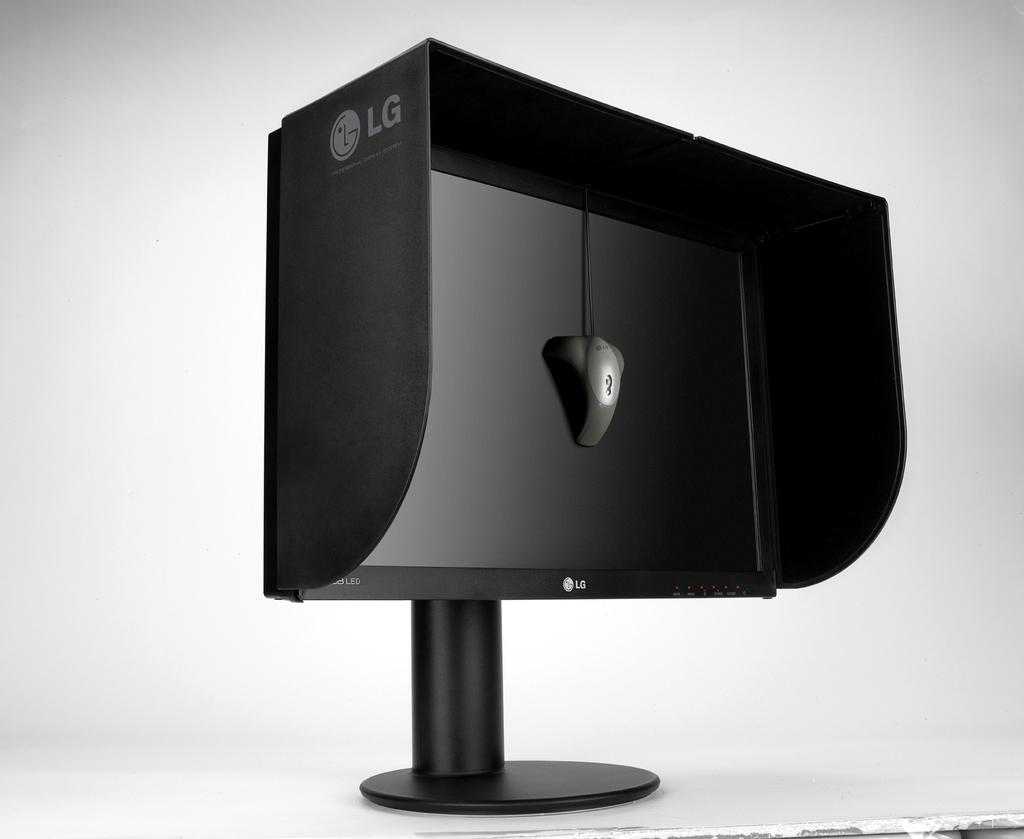<image>
Create a compact narrative representing the image presented. A monitor with a hood which has the letters LG on it. 